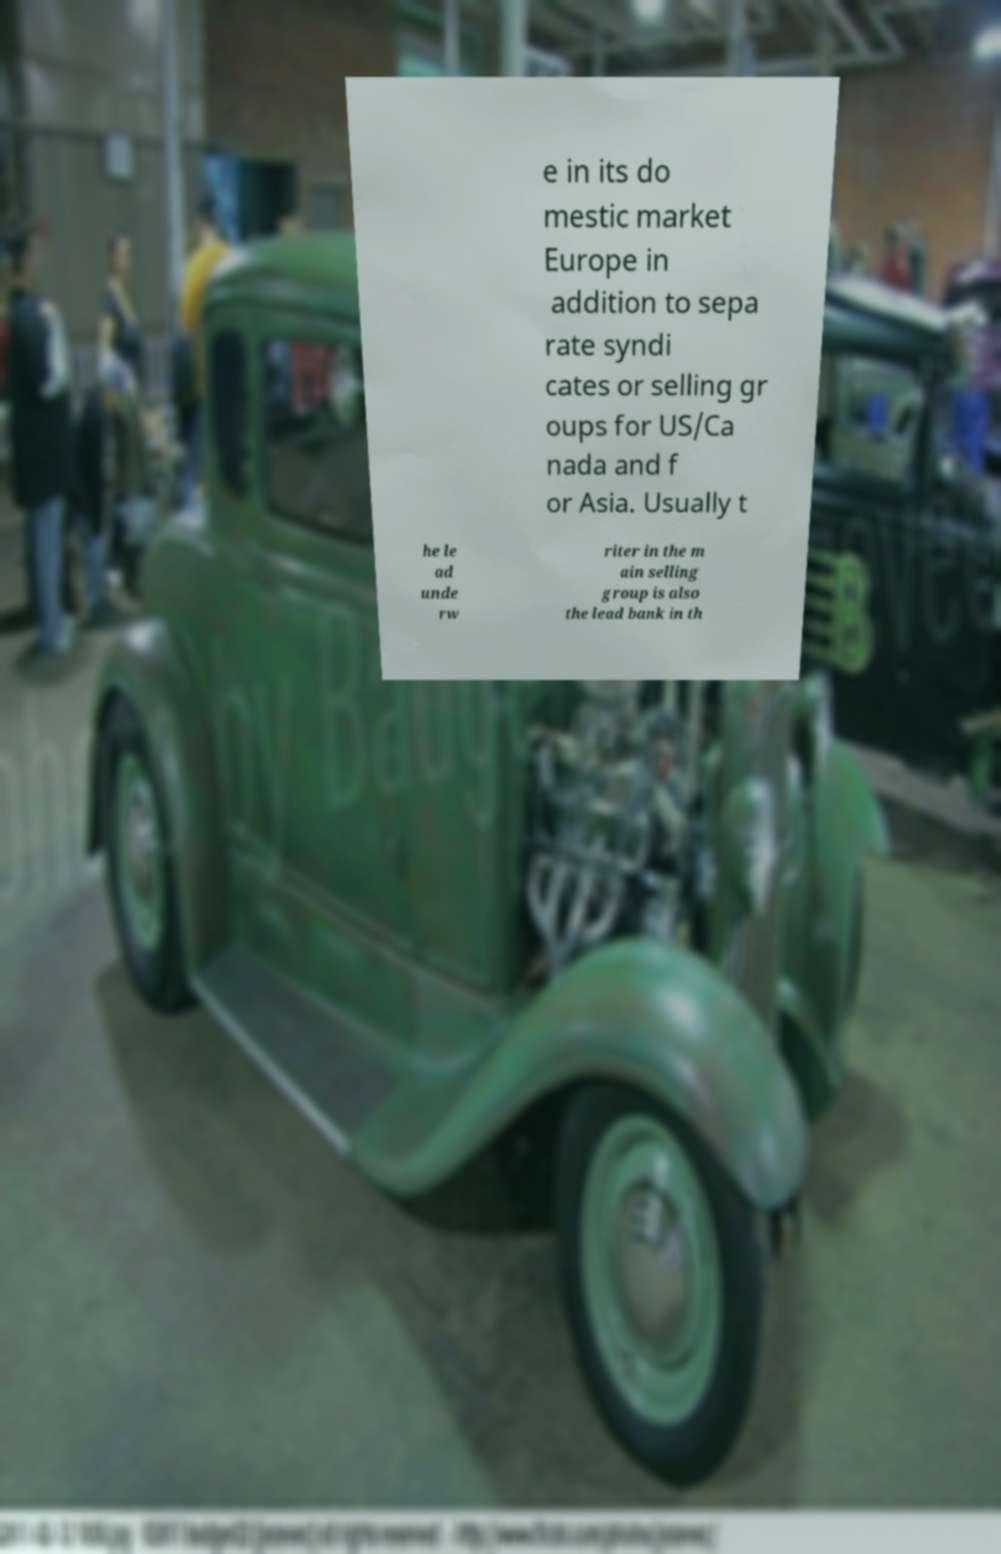Please identify and transcribe the text found in this image. e in its do mestic market Europe in addition to sepa rate syndi cates or selling gr oups for US/Ca nada and f or Asia. Usually t he le ad unde rw riter in the m ain selling group is also the lead bank in th 